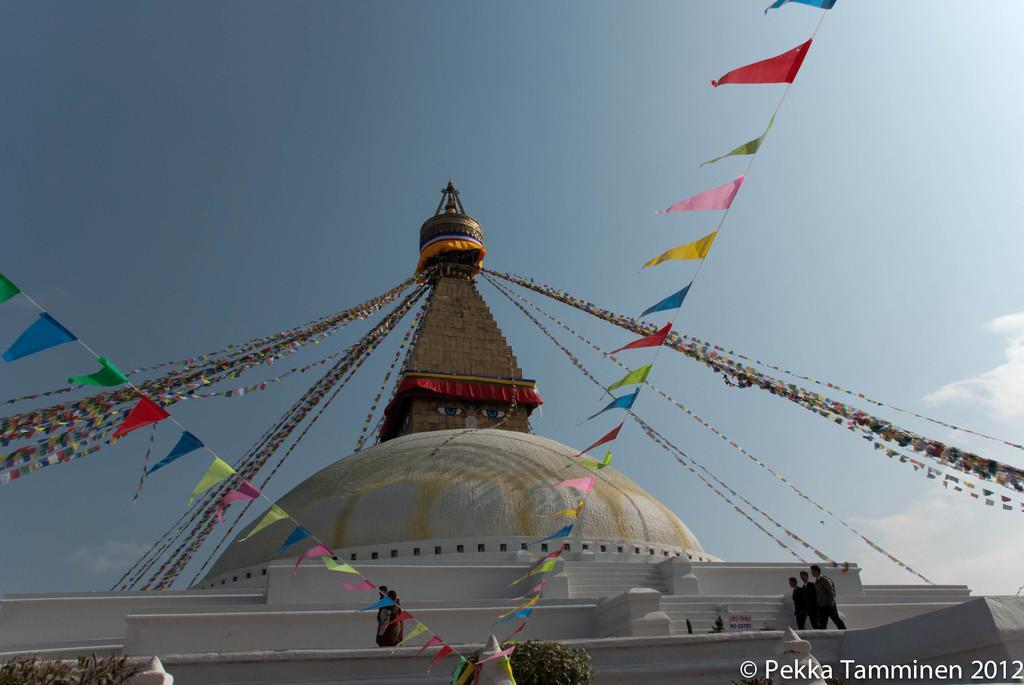In one or two sentences, can you explain what this image depicts? At the bottom of the image there is a building, on the building few people are standing and there are some plants. At the top of the image there are some clouds and sky. 